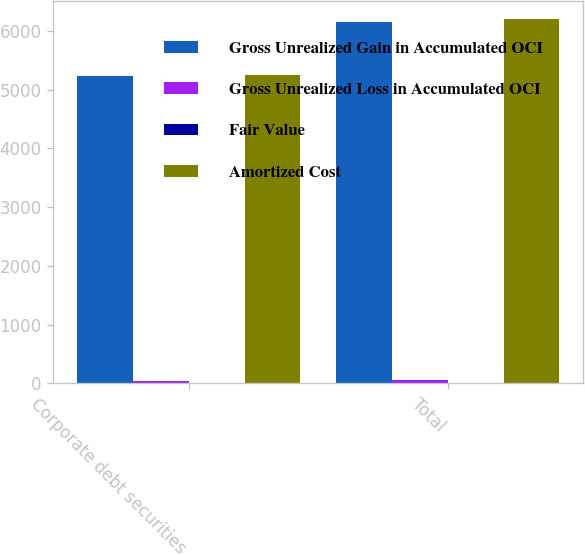Convert chart to OTSL. <chart><loc_0><loc_0><loc_500><loc_500><stacked_bar_chart><ecel><fcel>Corporate debt securities<fcel>Total<nl><fcel>Gross Unrealized Gain in Accumulated OCI<fcel>5237<fcel>6156<nl><fcel>Gross Unrealized Loss in Accumulated OCI<fcel>30<fcel>55<nl><fcel>Fair Value<fcel>8<fcel>8<nl><fcel>Amortized Cost<fcel>5259<fcel>6203<nl></chart> 